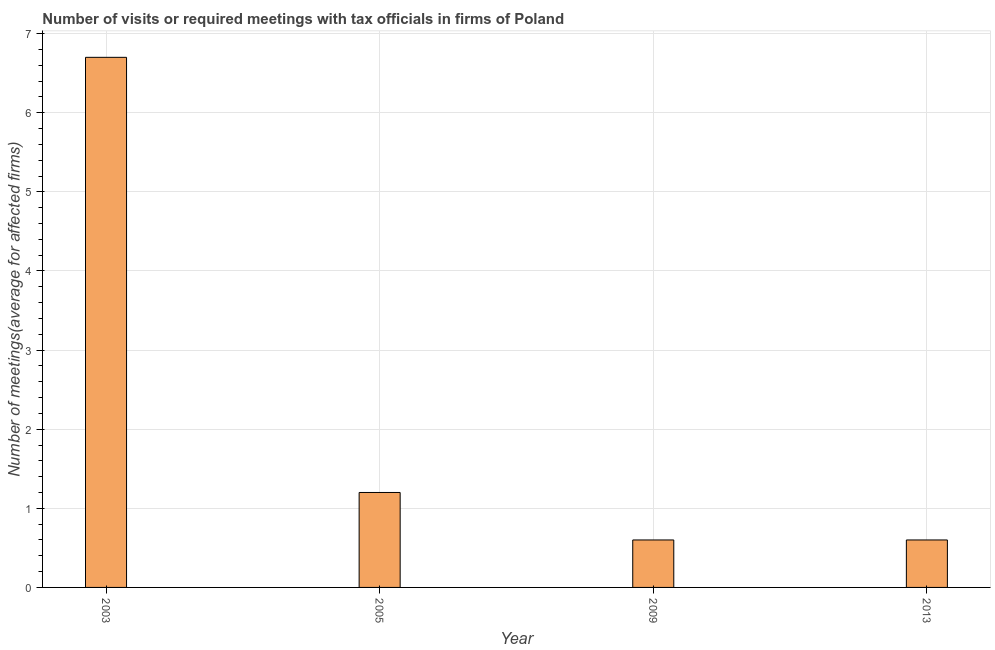Does the graph contain any zero values?
Ensure brevity in your answer.  No. Does the graph contain grids?
Your response must be concise. Yes. What is the title of the graph?
Give a very brief answer. Number of visits or required meetings with tax officials in firms of Poland. What is the label or title of the X-axis?
Your answer should be compact. Year. What is the label or title of the Y-axis?
Keep it short and to the point. Number of meetings(average for affected firms). Across all years, what is the maximum number of required meetings with tax officials?
Make the answer very short. 6.7. In which year was the number of required meetings with tax officials maximum?
Provide a succinct answer. 2003. What is the sum of the number of required meetings with tax officials?
Provide a succinct answer. 9.1. What is the difference between the number of required meetings with tax officials in 2005 and 2009?
Provide a succinct answer. 0.6. What is the average number of required meetings with tax officials per year?
Your answer should be very brief. 2.27. What is the median number of required meetings with tax officials?
Give a very brief answer. 0.9. In how many years, is the number of required meetings with tax officials greater than 0.4 ?
Give a very brief answer. 4. Do a majority of the years between 2009 and 2013 (inclusive) have number of required meetings with tax officials greater than 6.4 ?
Offer a terse response. No. What is the ratio of the number of required meetings with tax officials in 2003 to that in 2005?
Offer a very short reply. 5.58. Is the number of required meetings with tax officials in 2005 less than that in 2013?
Ensure brevity in your answer.  No. What is the difference between the highest and the second highest number of required meetings with tax officials?
Offer a terse response. 5.5. Is the sum of the number of required meetings with tax officials in 2005 and 2013 greater than the maximum number of required meetings with tax officials across all years?
Offer a terse response. No. How many bars are there?
Make the answer very short. 4. What is the Number of meetings(average for affected firms) in 2003?
Your answer should be very brief. 6.7. What is the Number of meetings(average for affected firms) of 2009?
Give a very brief answer. 0.6. What is the Number of meetings(average for affected firms) of 2013?
Keep it short and to the point. 0.6. What is the difference between the Number of meetings(average for affected firms) in 2003 and 2009?
Offer a very short reply. 6.1. What is the difference between the Number of meetings(average for affected firms) in 2003 and 2013?
Make the answer very short. 6.1. What is the difference between the Number of meetings(average for affected firms) in 2005 and 2009?
Your answer should be compact. 0.6. What is the ratio of the Number of meetings(average for affected firms) in 2003 to that in 2005?
Make the answer very short. 5.58. What is the ratio of the Number of meetings(average for affected firms) in 2003 to that in 2009?
Provide a succinct answer. 11.17. What is the ratio of the Number of meetings(average for affected firms) in 2003 to that in 2013?
Your response must be concise. 11.17. What is the ratio of the Number of meetings(average for affected firms) in 2009 to that in 2013?
Ensure brevity in your answer.  1. 